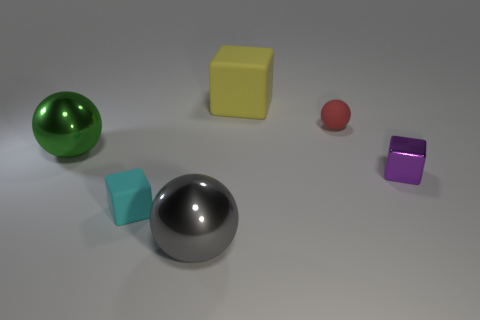There is a tiny cube that is left of the block that is behind the large green object that is on the left side of the cyan matte block; what color is it?
Make the answer very short. Cyan. There is a small matte object right of the large yellow block; is it the same shape as the small cyan matte object in front of the red rubber thing?
Offer a terse response. No. How many tiny red rubber things are there?
Your answer should be very brief. 1. The ball that is the same size as the purple object is what color?
Provide a short and direct response. Red. Do the small cube on the left side of the tiny ball and the sphere that is to the right of the yellow object have the same material?
Ensure brevity in your answer.  Yes. What is the size of the shiny ball behind the tiny object that is on the left side of the yellow object?
Your answer should be compact. Large. What material is the big ball that is left of the cyan rubber object?
Ensure brevity in your answer.  Metal. What number of things are shiny things that are right of the yellow cube or rubber objects in front of the green metallic ball?
Keep it short and to the point. 2. There is a cyan object that is the same shape as the yellow matte thing; what is it made of?
Offer a very short reply. Rubber. Do the tiny matte object in front of the purple metal block and the small thing that is behind the big green thing have the same color?
Provide a succinct answer. No. 